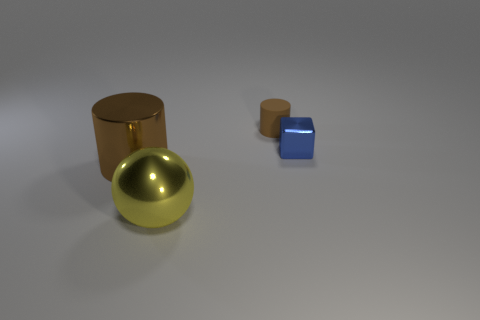Is there anything else that is the same shape as the blue shiny thing?
Make the answer very short. No. There is a object to the left of the yellow shiny sphere; what is its size?
Give a very brief answer. Large. What material is the brown object that is to the right of the big sphere in front of the small thing that is on the left side of the small blue metallic block made of?
Your response must be concise. Rubber. Is the shape of the small matte thing the same as the big brown thing?
Offer a very short reply. Yes. What number of metallic objects are big cylinders or small blocks?
Keep it short and to the point. 2. How many tiny things are there?
Your response must be concise. 2. There is a cylinder that is the same size as the yellow ball; what is its color?
Offer a terse response. Brown. Is the size of the brown matte object the same as the brown shiny object?
Your response must be concise. No. There is a small matte thing that is the same color as the big cylinder; what is its shape?
Offer a very short reply. Cylinder. There is a cube; does it have the same size as the cylinder that is in front of the shiny block?
Offer a terse response. No. 